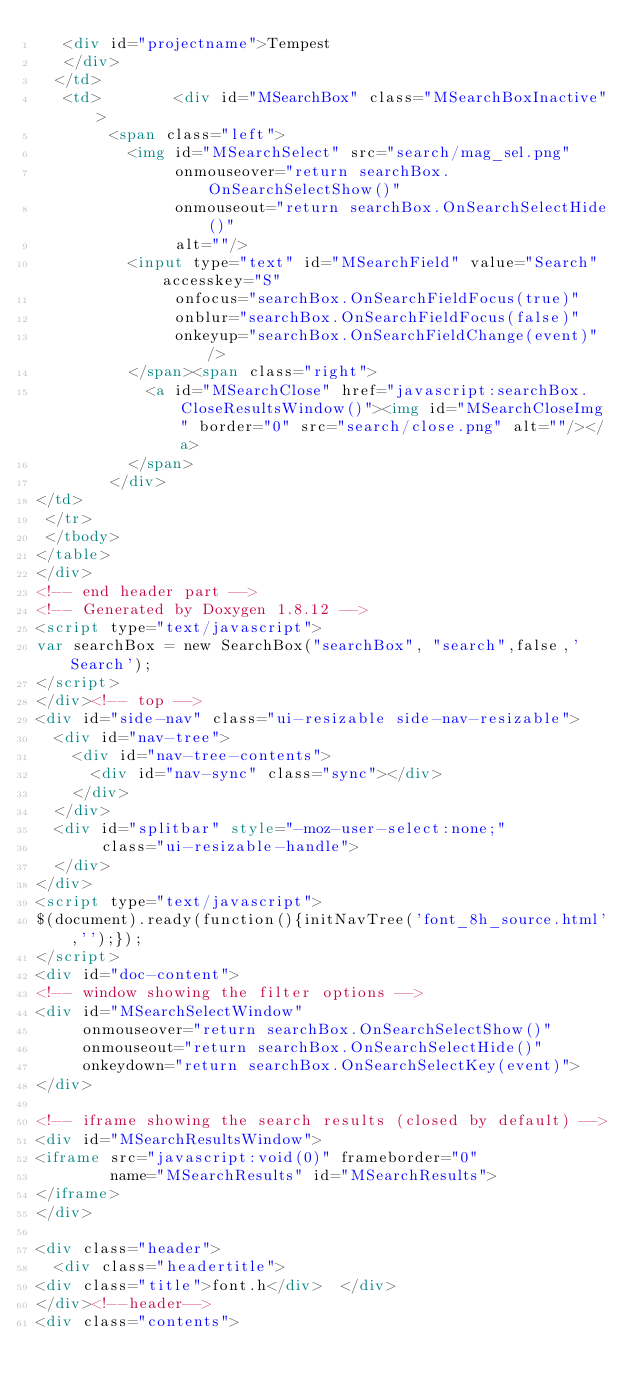<code> <loc_0><loc_0><loc_500><loc_500><_HTML_>   <div id="projectname">Tempest
   </div>
  </td>
   <td>        <div id="MSearchBox" class="MSearchBoxInactive">
        <span class="left">
          <img id="MSearchSelect" src="search/mag_sel.png"
               onmouseover="return searchBox.OnSearchSelectShow()"
               onmouseout="return searchBox.OnSearchSelectHide()"
               alt=""/>
          <input type="text" id="MSearchField" value="Search" accesskey="S"
               onfocus="searchBox.OnSearchFieldFocus(true)" 
               onblur="searchBox.OnSearchFieldFocus(false)" 
               onkeyup="searchBox.OnSearchFieldChange(event)"/>
          </span><span class="right">
            <a id="MSearchClose" href="javascript:searchBox.CloseResultsWindow()"><img id="MSearchCloseImg" border="0" src="search/close.png" alt=""/></a>
          </span>
        </div>
</td>
 </tr>
 </tbody>
</table>
</div>
<!-- end header part -->
<!-- Generated by Doxygen 1.8.12 -->
<script type="text/javascript">
var searchBox = new SearchBox("searchBox", "search",false,'Search');
</script>
</div><!-- top -->
<div id="side-nav" class="ui-resizable side-nav-resizable">
  <div id="nav-tree">
    <div id="nav-tree-contents">
      <div id="nav-sync" class="sync"></div>
    </div>
  </div>
  <div id="splitbar" style="-moz-user-select:none;" 
       class="ui-resizable-handle">
  </div>
</div>
<script type="text/javascript">
$(document).ready(function(){initNavTree('font_8h_source.html','');});
</script>
<div id="doc-content">
<!-- window showing the filter options -->
<div id="MSearchSelectWindow"
     onmouseover="return searchBox.OnSearchSelectShow()"
     onmouseout="return searchBox.OnSearchSelectHide()"
     onkeydown="return searchBox.OnSearchSelectKey(event)">
</div>

<!-- iframe showing the search results (closed by default) -->
<div id="MSearchResultsWindow">
<iframe src="javascript:void(0)" frameborder="0" 
        name="MSearchResults" id="MSearchResults">
</iframe>
</div>

<div class="header">
  <div class="headertitle">
<div class="title">font.h</div>  </div>
</div><!--header-->
<div class="contents"></code> 